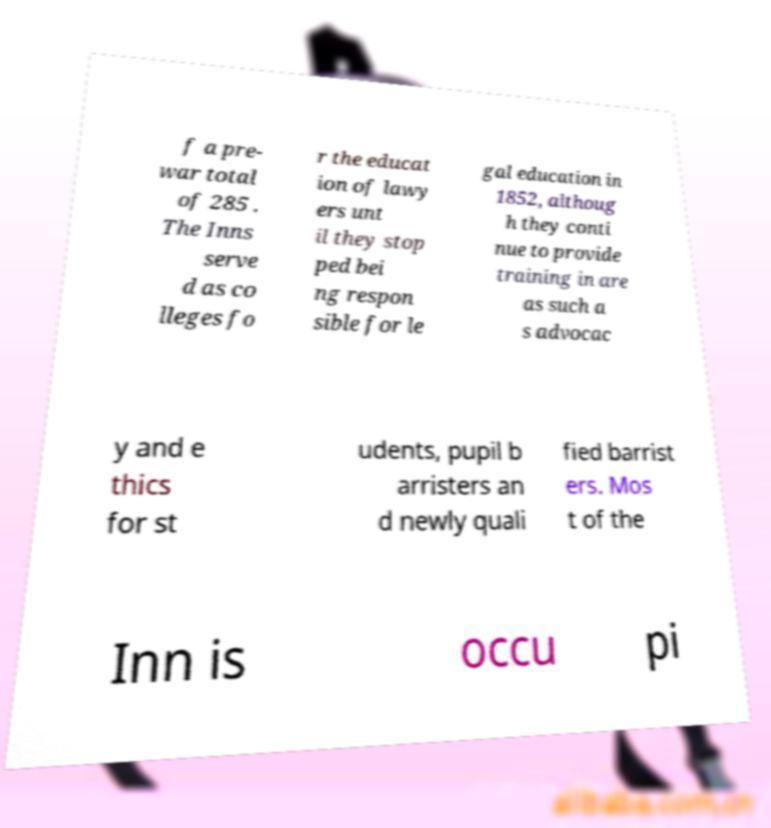Please read and relay the text visible in this image. What does it say? f a pre- war total of 285 . The Inns serve d as co lleges fo r the educat ion of lawy ers unt il they stop ped bei ng respon sible for le gal education in 1852, althoug h they conti nue to provide training in are as such a s advocac y and e thics for st udents, pupil b arristers an d newly quali fied barrist ers. Mos t of the Inn is occu pi 